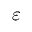Convert formula to latex. <formula><loc_0><loc_0><loc_500><loc_500>\varepsilon</formula> 